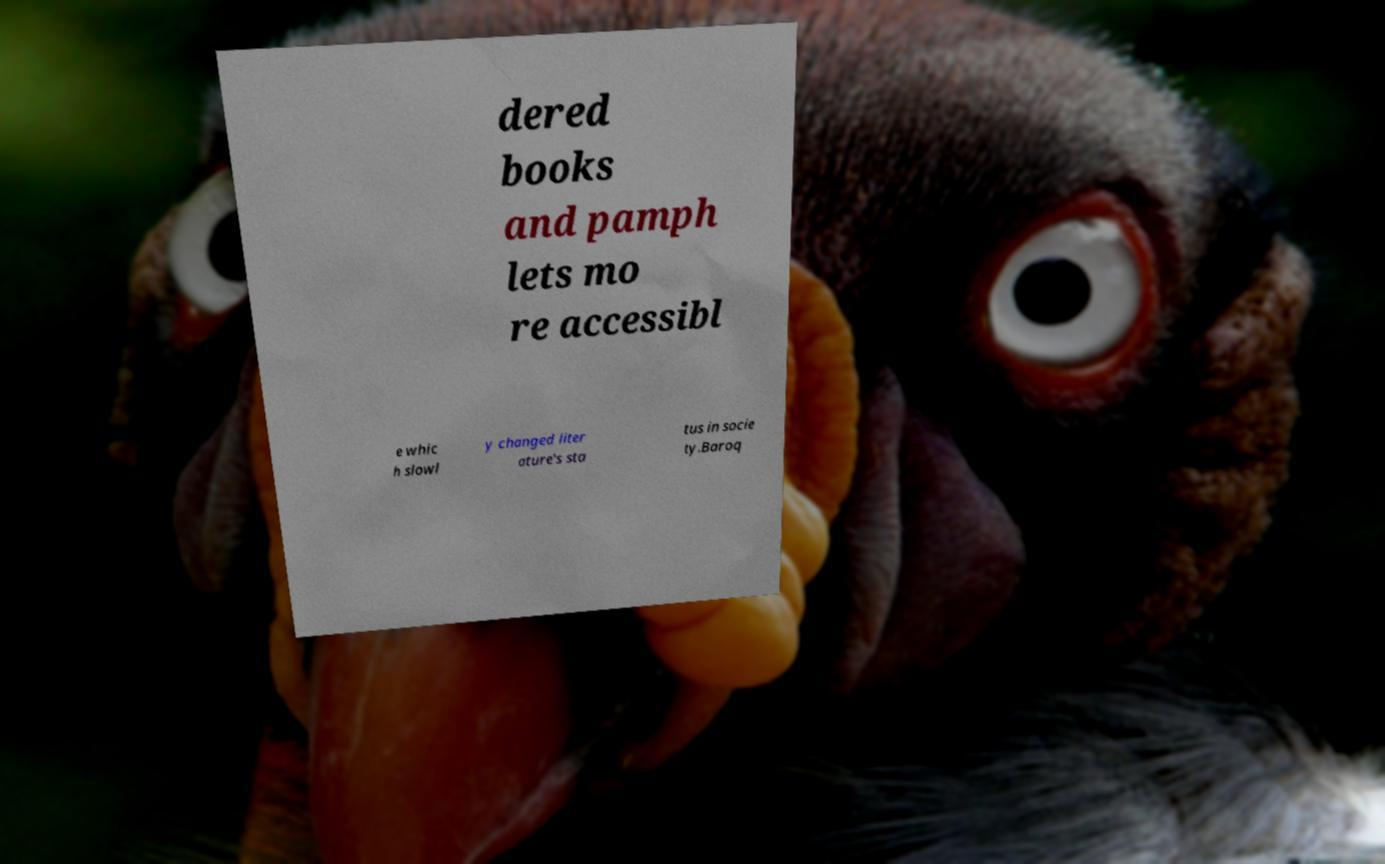Could you assist in decoding the text presented in this image and type it out clearly? dered books and pamph lets mo re accessibl e whic h slowl y changed liter ature's sta tus in socie ty.Baroq 